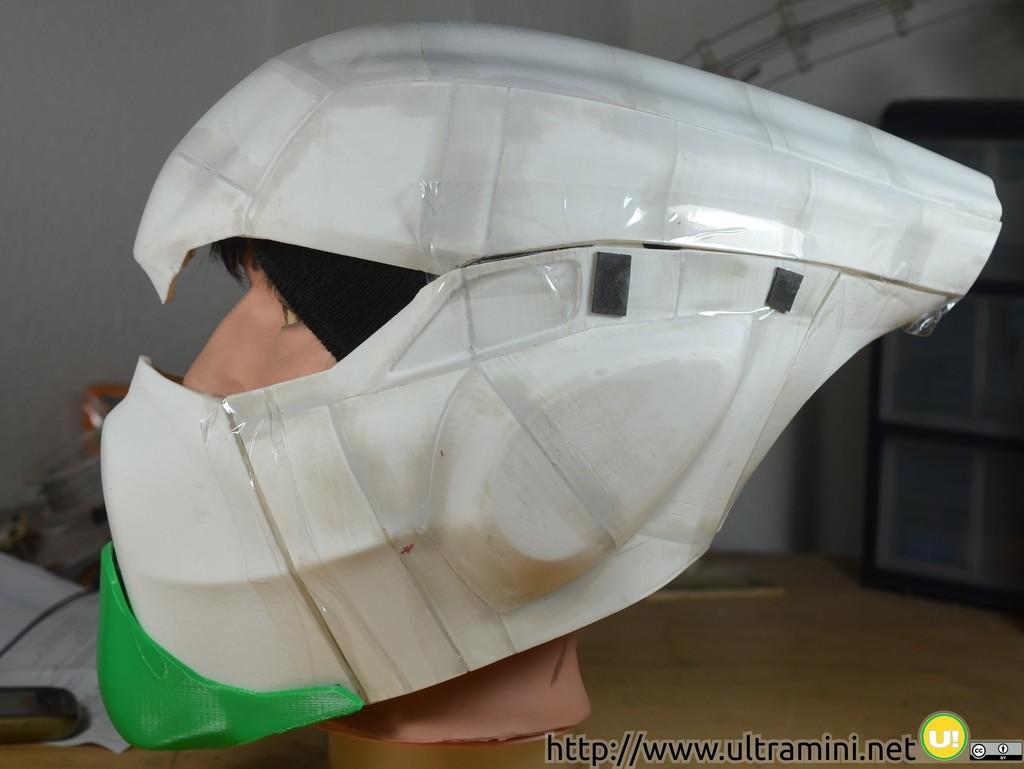How would you summarize this image in a sentence or two? In this picture there is a model of human face under a helmet. 